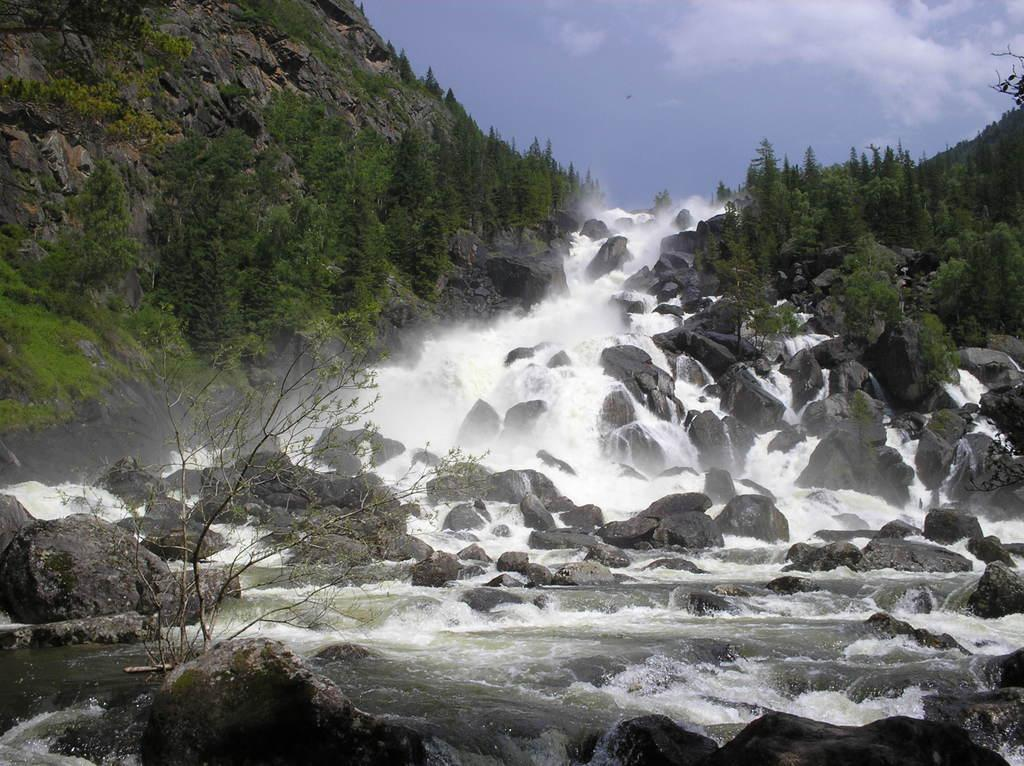What is the primary element visible in the image? There is water in the image. What can be seen on either side of the water? There are trees on either side of the water. What is present at the bottom of the water? Rocks are present at the bottom of the water. Can you see any bananas floating in the water in the image? There are no bananas visible in the image; it features water with trees on either side and rocks at the bottom. Is anyone wearing a mask in the image? There are no people or masks present in the image. 